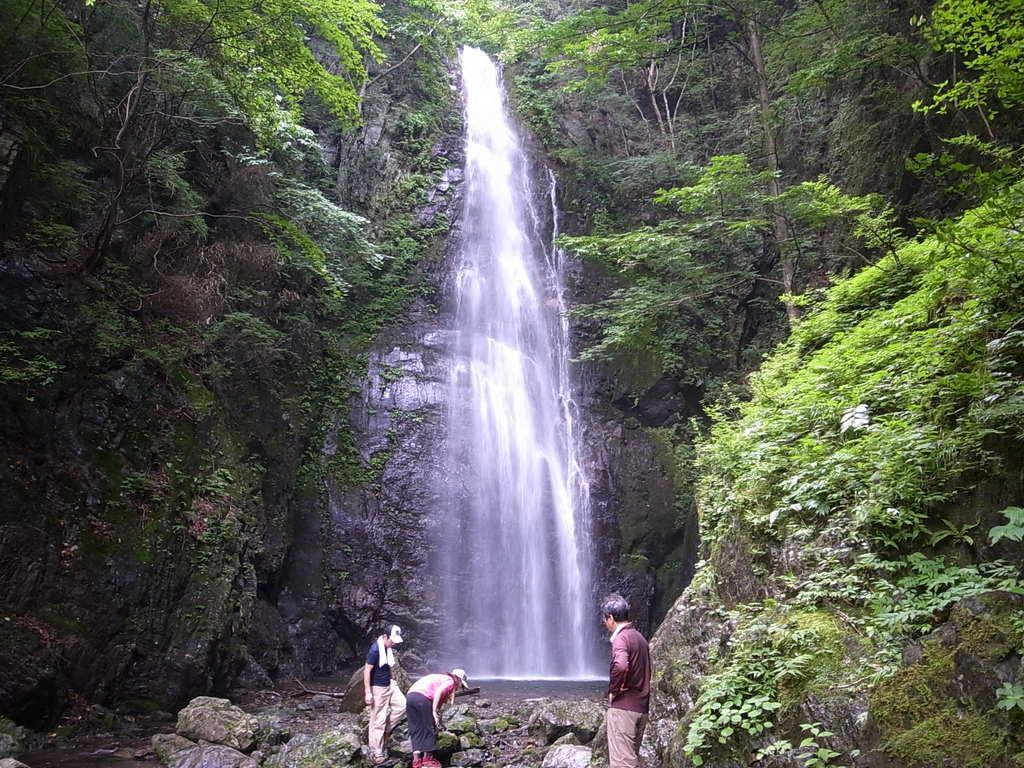How many people are in the foreground of the image? There are three persons standing in the foreground of the image. What are the persons standing on? The persons are standing on stones. What can be seen on either side of the image? There are rocks and trees on either side of the image. What is visible in the background of the image? There is a waterfall in the background of the image. What type of pig can be seen playing with a worm in the image? There is no pig or worm present in the image; it features three persons standing on stones, rocks and trees on either side, and a waterfall in the background. 